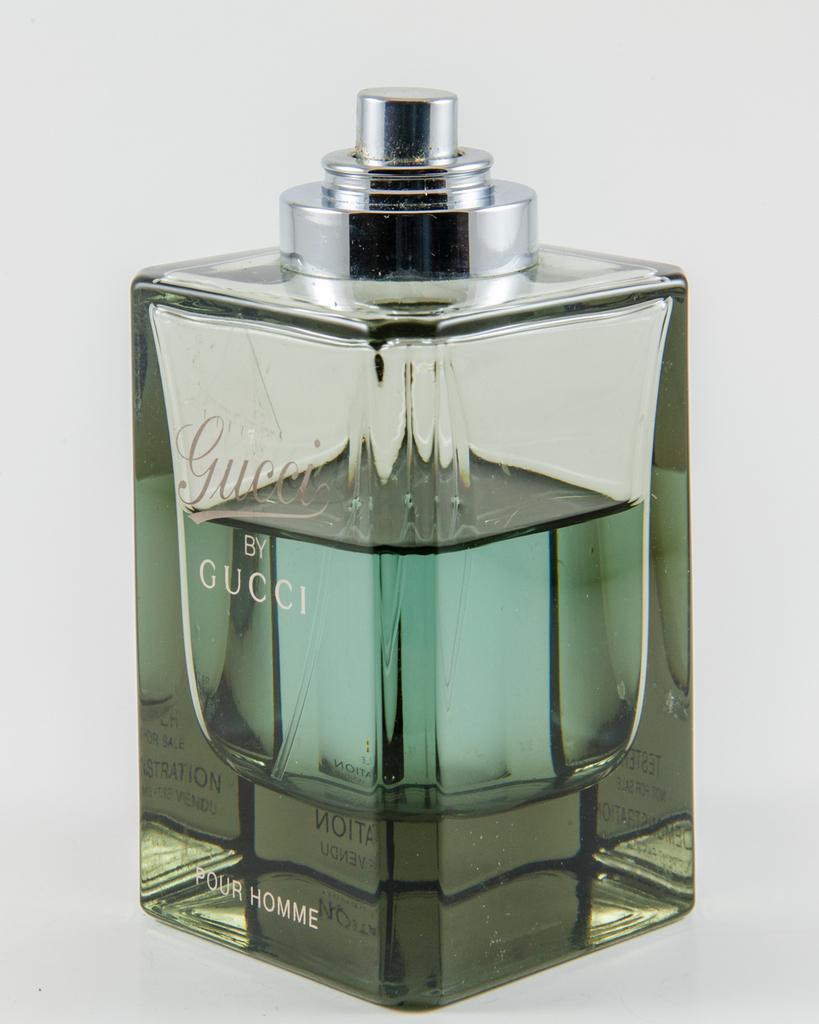What 2 words are at the bottom of the cologne tester?
Your answer should be compact. Pour homme. 